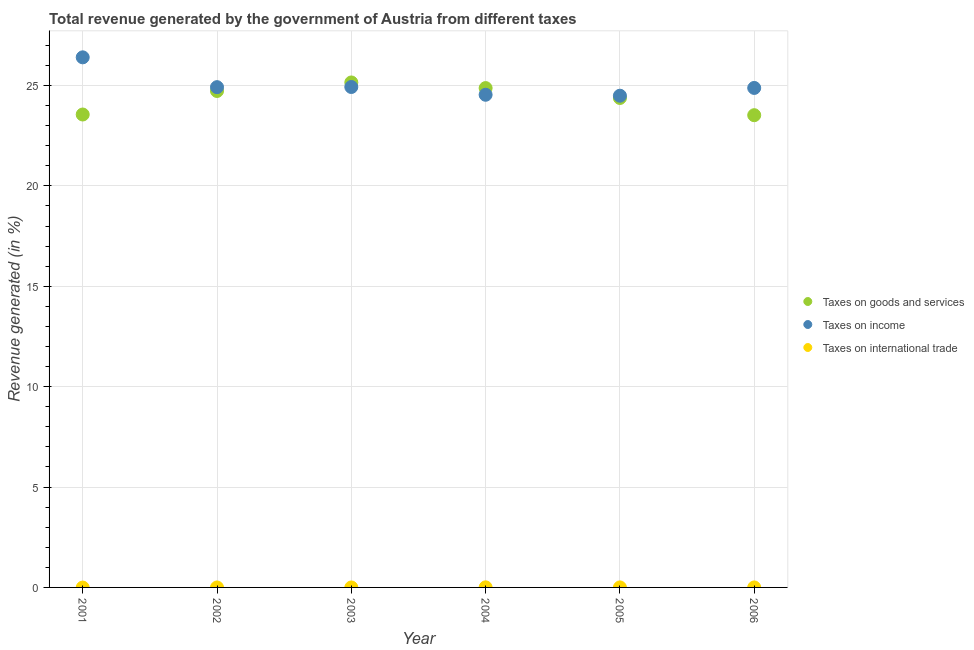Is the number of dotlines equal to the number of legend labels?
Make the answer very short. No. What is the percentage of revenue generated by tax on international trade in 2004?
Provide a succinct answer. 0. Across all years, what is the maximum percentage of revenue generated by tax on international trade?
Make the answer very short. 0. Across all years, what is the minimum percentage of revenue generated by tax on international trade?
Give a very brief answer. 0. In which year was the percentage of revenue generated by tax on international trade maximum?
Provide a succinct answer. 2004. What is the total percentage of revenue generated by tax on international trade in the graph?
Provide a succinct answer. 0.01. What is the difference between the percentage of revenue generated by taxes on goods and services in 2001 and that in 2004?
Offer a very short reply. -1.32. What is the difference between the percentage of revenue generated by taxes on income in 2002 and the percentage of revenue generated by tax on international trade in 2005?
Provide a short and direct response. 24.92. What is the average percentage of revenue generated by tax on international trade per year?
Offer a terse response. 0. In the year 2006, what is the difference between the percentage of revenue generated by taxes on goods and services and percentage of revenue generated by taxes on income?
Offer a terse response. -1.36. In how many years, is the percentage of revenue generated by taxes on goods and services greater than 2 %?
Your response must be concise. 6. What is the ratio of the percentage of revenue generated by taxes on income in 2002 to that in 2003?
Your answer should be compact. 1. What is the difference between the highest and the second highest percentage of revenue generated by taxes on income?
Your answer should be compact. 1.48. What is the difference between the highest and the lowest percentage of revenue generated by tax on international trade?
Provide a short and direct response. 0. Is it the case that in every year, the sum of the percentage of revenue generated by taxes on goods and services and percentage of revenue generated by taxes on income is greater than the percentage of revenue generated by tax on international trade?
Offer a very short reply. Yes. Does the percentage of revenue generated by taxes on income monotonically increase over the years?
Keep it short and to the point. No. Is the percentage of revenue generated by taxes on goods and services strictly greater than the percentage of revenue generated by taxes on income over the years?
Ensure brevity in your answer.  No. How many years are there in the graph?
Offer a terse response. 6. What is the difference between two consecutive major ticks on the Y-axis?
Make the answer very short. 5. Does the graph contain any zero values?
Give a very brief answer. Yes. How many legend labels are there?
Your response must be concise. 3. How are the legend labels stacked?
Your response must be concise. Vertical. What is the title of the graph?
Your answer should be very brief. Total revenue generated by the government of Austria from different taxes. What is the label or title of the Y-axis?
Give a very brief answer. Revenue generated (in %). What is the Revenue generated (in %) in Taxes on goods and services in 2001?
Your answer should be compact. 23.55. What is the Revenue generated (in %) in Taxes on income in 2001?
Give a very brief answer. 26.4. What is the Revenue generated (in %) of Taxes on goods and services in 2002?
Make the answer very short. 24.73. What is the Revenue generated (in %) in Taxes on income in 2002?
Give a very brief answer. 24.92. What is the Revenue generated (in %) in Taxes on international trade in 2002?
Your answer should be compact. 0. What is the Revenue generated (in %) in Taxes on goods and services in 2003?
Provide a succinct answer. 25.15. What is the Revenue generated (in %) in Taxes on income in 2003?
Your answer should be compact. 24.92. What is the Revenue generated (in %) of Taxes on goods and services in 2004?
Provide a short and direct response. 24.87. What is the Revenue generated (in %) in Taxes on income in 2004?
Make the answer very short. 24.54. What is the Revenue generated (in %) in Taxes on international trade in 2004?
Offer a very short reply. 0. What is the Revenue generated (in %) in Taxes on goods and services in 2005?
Make the answer very short. 24.38. What is the Revenue generated (in %) of Taxes on income in 2005?
Your response must be concise. 24.49. What is the Revenue generated (in %) of Taxes on international trade in 2005?
Your answer should be very brief. 0. What is the Revenue generated (in %) of Taxes on goods and services in 2006?
Provide a succinct answer. 23.52. What is the Revenue generated (in %) of Taxes on income in 2006?
Make the answer very short. 24.88. What is the Revenue generated (in %) of Taxes on international trade in 2006?
Make the answer very short. 7.23475776067297e-5. Across all years, what is the maximum Revenue generated (in %) in Taxes on goods and services?
Offer a terse response. 25.15. Across all years, what is the maximum Revenue generated (in %) in Taxes on income?
Make the answer very short. 26.4. Across all years, what is the maximum Revenue generated (in %) in Taxes on international trade?
Provide a succinct answer. 0. Across all years, what is the minimum Revenue generated (in %) in Taxes on goods and services?
Make the answer very short. 23.52. Across all years, what is the minimum Revenue generated (in %) in Taxes on income?
Provide a short and direct response. 24.49. Across all years, what is the minimum Revenue generated (in %) of Taxes on international trade?
Offer a terse response. 0. What is the total Revenue generated (in %) of Taxes on goods and services in the graph?
Offer a terse response. 146.2. What is the total Revenue generated (in %) in Taxes on income in the graph?
Your answer should be compact. 150.15. What is the total Revenue generated (in %) of Taxes on international trade in the graph?
Keep it short and to the point. 0.01. What is the difference between the Revenue generated (in %) in Taxes on goods and services in 2001 and that in 2002?
Give a very brief answer. -1.17. What is the difference between the Revenue generated (in %) in Taxes on income in 2001 and that in 2002?
Keep it short and to the point. 1.48. What is the difference between the Revenue generated (in %) in Taxes on goods and services in 2001 and that in 2003?
Offer a very short reply. -1.6. What is the difference between the Revenue generated (in %) of Taxes on income in 2001 and that in 2003?
Make the answer very short. 1.48. What is the difference between the Revenue generated (in %) of Taxes on goods and services in 2001 and that in 2004?
Your response must be concise. -1.32. What is the difference between the Revenue generated (in %) in Taxes on income in 2001 and that in 2004?
Offer a very short reply. 1.86. What is the difference between the Revenue generated (in %) in Taxes on goods and services in 2001 and that in 2005?
Ensure brevity in your answer.  -0.82. What is the difference between the Revenue generated (in %) of Taxes on income in 2001 and that in 2005?
Your answer should be compact. 1.91. What is the difference between the Revenue generated (in %) of Taxes on goods and services in 2001 and that in 2006?
Provide a short and direct response. 0.03. What is the difference between the Revenue generated (in %) of Taxes on income in 2001 and that in 2006?
Your answer should be compact. 1.52. What is the difference between the Revenue generated (in %) in Taxes on goods and services in 2002 and that in 2003?
Offer a terse response. -0.42. What is the difference between the Revenue generated (in %) in Taxes on income in 2002 and that in 2003?
Provide a short and direct response. -0.01. What is the difference between the Revenue generated (in %) of Taxes on goods and services in 2002 and that in 2004?
Ensure brevity in your answer.  -0.14. What is the difference between the Revenue generated (in %) in Taxes on income in 2002 and that in 2004?
Your response must be concise. 0.38. What is the difference between the Revenue generated (in %) of Taxes on goods and services in 2002 and that in 2005?
Keep it short and to the point. 0.35. What is the difference between the Revenue generated (in %) in Taxes on income in 2002 and that in 2005?
Offer a very short reply. 0.43. What is the difference between the Revenue generated (in %) of Taxes on goods and services in 2002 and that in 2006?
Make the answer very short. 1.21. What is the difference between the Revenue generated (in %) in Taxes on income in 2002 and that in 2006?
Ensure brevity in your answer.  0.04. What is the difference between the Revenue generated (in %) in Taxes on goods and services in 2003 and that in 2004?
Provide a succinct answer. 0.28. What is the difference between the Revenue generated (in %) of Taxes on income in 2003 and that in 2004?
Your answer should be compact. 0.39. What is the difference between the Revenue generated (in %) of Taxes on goods and services in 2003 and that in 2005?
Ensure brevity in your answer.  0.77. What is the difference between the Revenue generated (in %) of Taxes on income in 2003 and that in 2005?
Provide a succinct answer. 0.43. What is the difference between the Revenue generated (in %) of Taxes on goods and services in 2003 and that in 2006?
Ensure brevity in your answer.  1.63. What is the difference between the Revenue generated (in %) in Taxes on income in 2003 and that in 2006?
Offer a terse response. 0.05. What is the difference between the Revenue generated (in %) of Taxes on goods and services in 2004 and that in 2005?
Keep it short and to the point. 0.49. What is the difference between the Revenue generated (in %) of Taxes on income in 2004 and that in 2005?
Your response must be concise. 0.05. What is the difference between the Revenue generated (in %) of Taxes on international trade in 2004 and that in 2005?
Give a very brief answer. 0. What is the difference between the Revenue generated (in %) of Taxes on goods and services in 2004 and that in 2006?
Keep it short and to the point. 1.35. What is the difference between the Revenue generated (in %) of Taxes on income in 2004 and that in 2006?
Give a very brief answer. -0.34. What is the difference between the Revenue generated (in %) in Taxes on international trade in 2004 and that in 2006?
Offer a terse response. 0. What is the difference between the Revenue generated (in %) of Taxes on goods and services in 2005 and that in 2006?
Provide a succinct answer. 0.86. What is the difference between the Revenue generated (in %) of Taxes on income in 2005 and that in 2006?
Offer a terse response. -0.39. What is the difference between the Revenue generated (in %) of Taxes on international trade in 2005 and that in 2006?
Provide a short and direct response. 0. What is the difference between the Revenue generated (in %) in Taxes on goods and services in 2001 and the Revenue generated (in %) in Taxes on income in 2002?
Your answer should be very brief. -1.36. What is the difference between the Revenue generated (in %) in Taxes on goods and services in 2001 and the Revenue generated (in %) in Taxes on income in 2003?
Offer a very short reply. -1.37. What is the difference between the Revenue generated (in %) in Taxes on goods and services in 2001 and the Revenue generated (in %) in Taxes on income in 2004?
Keep it short and to the point. -0.98. What is the difference between the Revenue generated (in %) in Taxes on goods and services in 2001 and the Revenue generated (in %) in Taxes on international trade in 2004?
Give a very brief answer. 23.55. What is the difference between the Revenue generated (in %) of Taxes on income in 2001 and the Revenue generated (in %) of Taxes on international trade in 2004?
Ensure brevity in your answer.  26.4. What is the difference between the Revenue generated (in %) in Taxes on goods and services in 2001 and the Revenue generated (in %) in Taxes on income in 2005?
Make the answer very short. -0.94. What is the difference between the Revenue generated (in %) of Taxes on goods and services in 2001 and the Revenue generated (in %) of Taxes on international trade in 2005?
Provide a succinct answer. 23.55. What is the difference between the Revenue generated (in %) of Taxes on income in 2001 and the Revenue generated (in %) of Taxes on international trade in 2005?
Offer a terse response. 26.4. What is the difference between the Revenue generated (in %) of Taxes on goods and services in 2001 and the Revenue generated (in %) of Taxes on income in 2006?
Keep it short and to the point. -1.32. What is the difference between the Revenue generated (in %) in Taxes on goods and services in 2001 and the Revenue generated (in %) in Taxes on international trade in 2006?
Provide a succinct answer. 23.55. What is the difference between the Revenue generated (in %) in Taxes on income in 2001 and the Revenue generated (in %) in Taxes on international trade in 2006?
Ensure brevity in your answer.  26.4. What is the difference between the Revenue generated (in %) in Taxes on goods and services in 2002 and the Revenue generated (in %) in Taxes on income in 2003?
Provide a succinct answer. -0.2. What is the difference between the Revenue generated (in %) in Taxes on goods and services in 2002 and the Revenue generated (in %) in Taxes on income in 2004?
Offer a very short reply. 0.19. What is the difference between the Revenue generated (in %) in Taxes on goods and services in 2002 and the Revenue generated (in %) in Taxes on international trade in 2004?
Give a very brief answer. 24.72. What is the difference between the Revenue generated (in %) of Taxes on income in 2002 and the Revenue generated (in %) of Taxes on international trade in 2004?
Offer a very short reply. 24.91. What is the difference between the Revenue generated (in %) of Taxes on goods and services in 2002 and the Revenue generated (in %) of Taxes on income in 2005?
Offer a very short reply. 0.24. What is the difference between the Revenue generated (in %) of Taxes on goods and services in 2002 and the Revenue generated (in %) of Taxes on international trade in 2005?
Your answer should be compact. 24.72. What is the difference between the Revenue generated (in %) in Taxes on income in 2002 and the Revenue generated (in %) in Taxes on international trade in 2005?
Make the answer very short. 24.91. What is the difference between the Revenue generated (in %) of Taxes on goods and services in 2002 and the Revenue generated (in %) of Taxes on income in 2006?
Your response must be concise. -0.15. What is the difference between the Revenue generated (in %) of Taxes on goods and services in 2002 and the Revenue generated (in %) of Taxes on international trade in 2006?
Your response must be concise. 24.73. What is the difference between the Revenue generated (in %) in Taxes on income in 2002 and the Revenue generated (in %) in Taxes on international trade in 2006?
Make the answer very short. 24.92. What is the difference between the Revenue generated (in %) in Taxes on goods and services in 2003 and the Revenue generated (in %) in Taxes on income in 2004?
Your answer should be compact. 0.61. What is the difference between the Revenue generated (in %) of Taxes on goods and services in 2003 and the Revenue generated (in %) of Taxes on international trade in 2004?
Ensure brevity in your answer.  25.15. What is the difference between the Revenue generated (in %) of Taxes on income in 2003 and the Revenue generated (in %) of Taxes on international trade in 2004?
Your answer should be very brief. 24.92. What is the difference between the Revenue generated (in %) in Taxes on goods and services in 2003 and the Revenue generated (in %) in Taxes on income in 2005?
Ensure brevity in your answer.  0.66. What is the difference between the Revenue generated (in %) in Taxes on goods and services in 2003 and the Revenue generated (in %) in Taxes on international trade in 2005?
Your answer should be very brief. 25.15. What is the difference between the Revenue generated (in %) in Taxes on income in 2003 and the Revenue generated (in %) in Taxes on international trade in 2005?
Provide a succinct answer. 24.92. What is the difference between the Revenue generated (in %) of Taxes on goods and services in 2003 and the Revenue generated (in %) of Taxes on income in 2006?
Offer a very short reply. 0.27. What is the difference between the Revenue generated (in %) of Taxes on goods and services in 2003 and the Revenue generated (in %) of Taxes on international trade in 2006?
Make the answer very short. 25.15. What is the difference between the Revenue generated (in %) in Taxes on income in 2003 and the Revenue generated (in %) in Taxes on international trade in 2006?
Offer a very short reply. 24.92. What is the difference between the Revenue generated (in %) of Taxes on goods and services in 2004 and the Revenue generated (in %) of Taxes on income in 2005?
Offer a terse response. 0.38. What is the difference between the Revenue generated (in %) in Taxes on goods and services in 2004 and the Revenue generated (in %) in Taxes on international trade in 2005?
Your answer should be compact. 24.87. What is the difference between the Revenue generated (in %) in Taxes on income in 2004 and the Revenue generated (in %) in Taxes on international trade in 2005?
Provide a succinct answer. 24.54. What is the difference between the Revenue generated (in %) of Taxes on goods and services in 2004 and the Revenue generated (in %) of Taxes on income in 2006?
Offer a very short reply. -0.01. What is the difference between the Revenue generated (in %) of Taxes on goods and services in 2004 and the Revenue generated (in %) of Taxes on international trade in 2006?
Your answer should be very brief. 24.87. What is the difference between the Revenue generated (in %) in Taxes on income in 2004 and the Revenue generated (in %) in Taxes on international trade in 2006?
Your response must be concise. 24.54. What is the difference between the Revenue generated (in %) in Taxes on goods and services in 2005 and the Revenue generated (in %) in Taxes on income in 2006?
Make the answer very short. -0.5. What is the difference between the Revenue generated (in %) in Taxes on goods and services in 2005 and the Revenue generated (in %) in Taxes on international trade in 2006?
Offer a very short reply. 24.38. What is the difference between the Revenue generated (in %) of Taxes on income in 2005 and the Revenue generated (in %) of Taxes on international trade in 2006?
Keep it short and to the point. 24.49. What is the average Revenue generated (in %) in Taxes on goods and services per year?
Offer a terse response. 24.37. What is the average Revenue generated (in %) of Taxes on income per year?
Make the answer very short. 25.02. In the year 2001, what is the difference between the Revenue generated (in %) in Taxes on goods and services and Revenue generated (in %) in Taxes on income?
Provide a succinct answer. -2.85. In the year 2002, what is the difference between the Revenue generated (in %) in Taxes on goods and services and Revenue generated (in %) in Taxes on income?
Provide a short and direct response. -0.19. In the year 2003, what is the difference between the Revenue generated (in %) of Taxes on goods and services and Revenue generated (in %) of Taxes on income?
Make the answer very short. 0.23. In the year 2004, what is the difference between the Revenue generated (in %) in Taxes on goods and services and Revenue generated (in %) in Taxes on income?
Offer a terse response. 0.33. In the year 2004, what is the difference between the Revenue generated (in %) in Taxes on goods and services and Revenue generated (in %) in Taxes on international trade?
Make the answer very short. 24.87. In the year 2004, what is the difference between the Revenue generated (in %) of Taxes on income and Revenue generated (in %) of Taxes on international trade?
Ensure brevity in your answer.  24.53. In the year 2005, what is the difference between the Revenue generated (in %) in Taxes on goods and services and Revenue generated (in %) in Taxes on income?
Give a very brief answer. -0.11. In the year 2005, what is the difference between the Revenue generated (in %) of Taxes on goods and services and Revenue generated (in %) of Taxes on international trade?
Your answer should be compact. 24.38. In the year 2005, what is the difference between the Revenue generated (in %) in Taxes on income and Revenue generated (in %) in Taxes on international trade?
Keep it short and to the point. 24.49. In the year 2006, what is the difference between the Revenue generated (in %) of Taxes on goods and services and Revenue generated (in %) of Taxes on income?
Keep it short and to the point. -1.36. In the year 2006, what is the difference between the Revenue generated (in %) in Taxes on goods and services and Revenue generated (in %) in Taxes on international trade?
Make the answer very short. 23.52. In the year 2006, what is the difference between the Revenue generated (in %) in Taxes on income and Revenue generated (in %) in Taxes on international trade?
Keep it short and to the point. 24.88. What is the ratio of the Revenue generated (in %) in Taxes on goods and services in 2001 to that in 2002?
Make the answer very short. 0.95. What is the ratio of the Revenue generated (in %) in Taxes on income in 2001 to that in 2002?
Offer a terse response. 1.06. What is the ratio of the Revenue generated (in %) in Taxes on goods and services in 2001 to that in 2003?
Your answer should be very brief. 0.94. What is the ratio of the Revenue generated (in %) in Taxes on income in 2001 to that in 2003?
Your response must be concise. 1.06. What is the ratio of the Revenue generated (in %) in Taxes on goods and services in 2001 to that in 2004?
Your answer should be compact. 0.95. What is the ratio of the Revenue generated (in %) in Taxes on income in 2001 to that in 2004?
Provide a short and direct response. 1.08. What is the ratio of the Revenue generated (in %) of Taxes on goods and services in 2001 to that in 2005?
Provide a short and direct response. 0.97. What is the ratio of the Revenue generated (in %) of Taxes on income in 2001 to that in 2005?
Give a very brief answer. 1.08. What is the ratio of the Revenue generated (in %) in Taxes on income in 2001 to that in 2006?
Offer a terse response. 1.06. What is the ratio of the Revenue generated (in %) of Taxes on goods and services in 2002 to that in 2003?
Your response must be concise. 0.98. What is the ratio of the Revenue generated (in %) in Taxes on goods and services in 2002 to that in 2004?
Your answer should be compact. 0.99. What is the ratio of the Revenue generated (in %) of Taxes on income in 2002 to that in 2004?
Ensure brevity in your answer.  1.02. What is the ratio of the Revenue generated (in %) in Taxes on goods and services in 2002 to that in 2005?
Offer a terse response. 1.01. What is the ratio of the Revenue generated (in %) in Taxes on income in 2002 to that in 2005?
Offer a terse response. 1.02. What is the ratio of the Revenue generated (in %) in Taxes on goods and services in 2002 to that in 2006?
Give a very brief answer. 1.05. What is the ratio of the Revenue generated (in %) in Taxes on income in 2002 to that in 2006?
Make the answer very short. 1. What is the ratio of the Revenue generated (in %) in Taxes on goods and services in 2003 to that in 2004?
Give a very brief answer. 1.01. What is the ratio of the Revenue generated (in %) in Taxes on income in 2003 to that in 2004?
Your answer should be compact. 1.02. What is the ratio of the Revenue generated (in %) in Taxes on goods and services in 2003 to that in 2005?
Offer a very short reply. 1.03. What is the ratio of the Revenue generated (in %) of Taxes on income in 2003 to that in 2005?
Keep it short and to the point. 1.02. What is the ratio of the Revenue generated (in %) in Taxes on goods and services in 2003 to that in 2006?
Ensure brevity in your answer.  1.07. What is the ratio of the Revenue generated (in %) of Taxes on goods and services in 2004 to that in 2005?
Offer a terse response. 1.02. What is the ratio of the Revenue generated (in %) in Taxes on international trade in 2004 to that in 2005?
Provide a succinct answer. 2.81. What is the ratio of the Revenue generated (in %) in Taxes on goods and services in 2004 to that in 2006?
Ensure brevity in your answer.  1.06. What is the ratio of the Revenue generated (in %) in Taxes on income in 2004 to that in 2006?
Ensure brevity in your answer.  0.99. What is the ratio of the Revenue generated (in %) in Taxes on international trade in 2004 to that in 2006?
Ensure brevity in your answer.  59.87. What is the ratio of the Revenue generated (in %) of Taxes on goods and services in 2005 to that in 2006?
Your response must be concise. 1.04. What is the ratio of the Revenue generated (in %) in Taxes on income in 2005 to that in 2006?
Keep it short and to the point. 0.98. What is the ratio of the Revenue generated (in %) in Taxes on international trade in 2005 to that in 2006?
Make the answer very short. 21.3. What is the difference between the highest and the second highest Revenue generated (in %) in Taxes on goods and services?
Give a very brief answer. 0.28. What is the difference between the highest and the second highest Revenue generated (in %) of Taxes on income?
Your answer should be very brief. 1.48. What is the difference between the highest and the second highest Revenue generated (in %) in Taxes on international trade?
Your answer should be very brief. 0. What is the difference between the highest and the lowest Revenue generated (in %) in Taxes on goods and services?
Make the answer very short. 1.63. What is the difference between the highest and the lowest Revenue generated (in %) in Taxes on income?
Offer a very short reply. 1.91. What is the difference between the highest and the lowest Revenue generated (in %) of Taxes on international trade?
Offer a terse response. 0. 